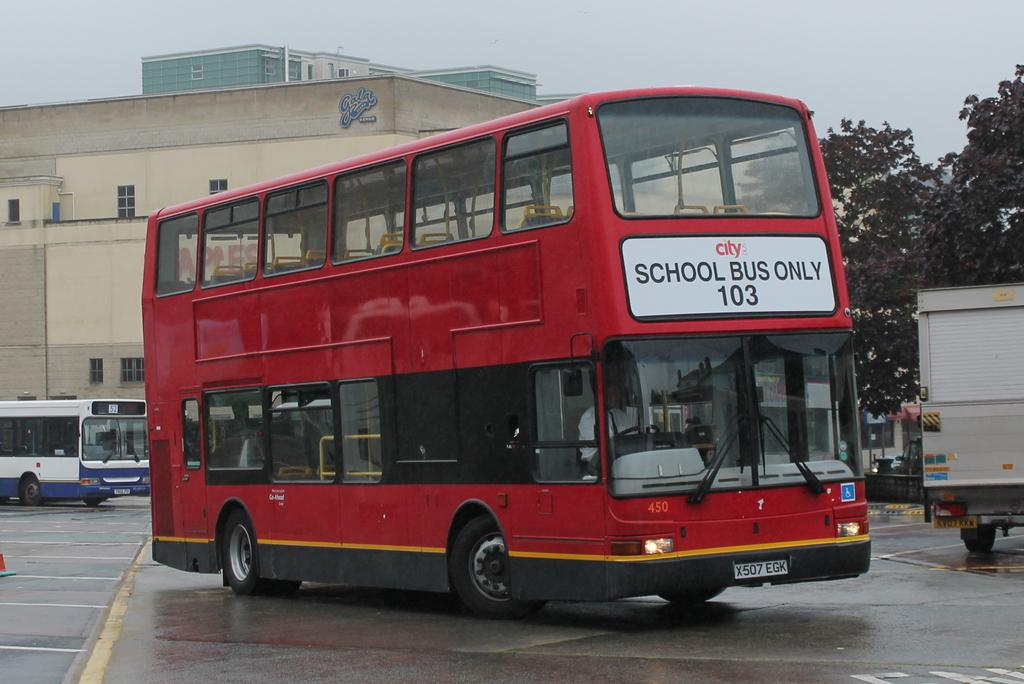Provide a one-sentence caption for the provided image. a double stacked red bus number 103 written on the front. 